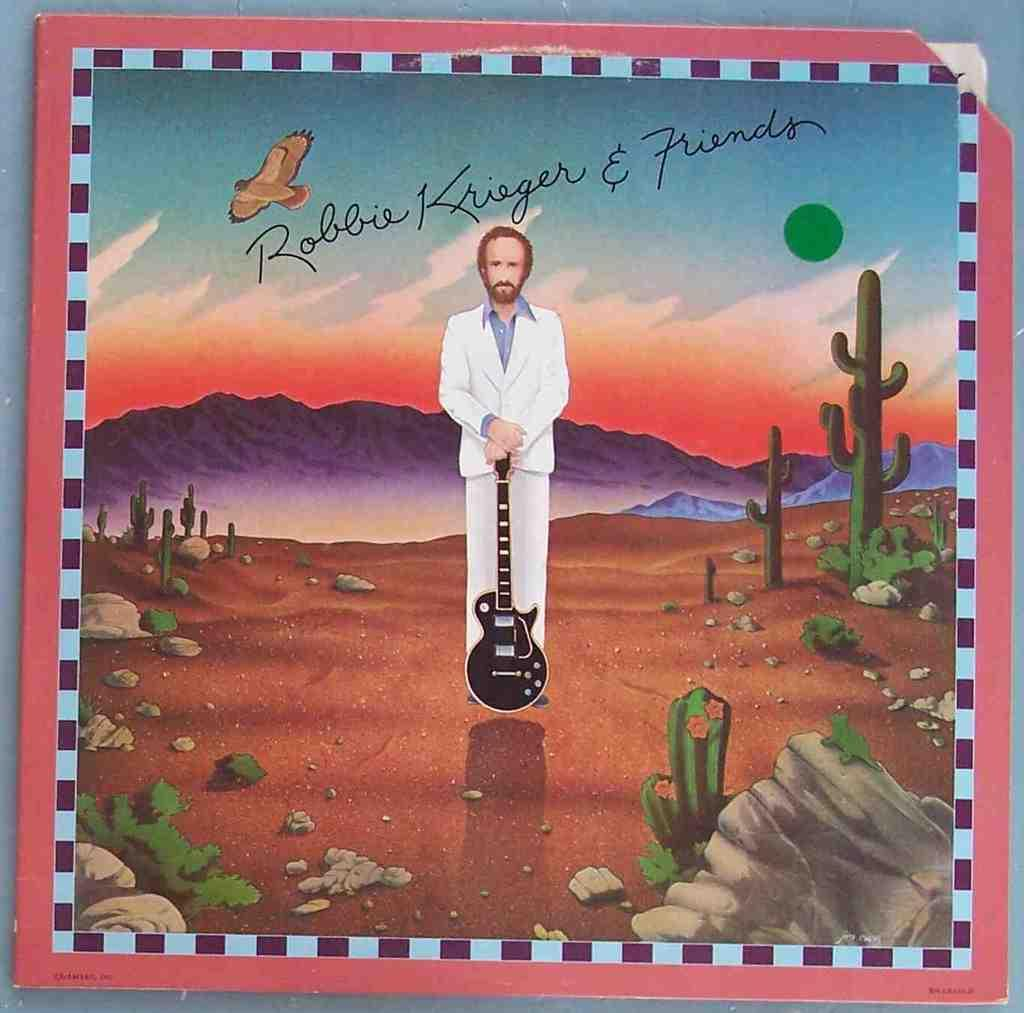Provide a one-sentence caption for the provided image. An illustration of a man holding a guitar signed "Robbie Krieger and friends". 